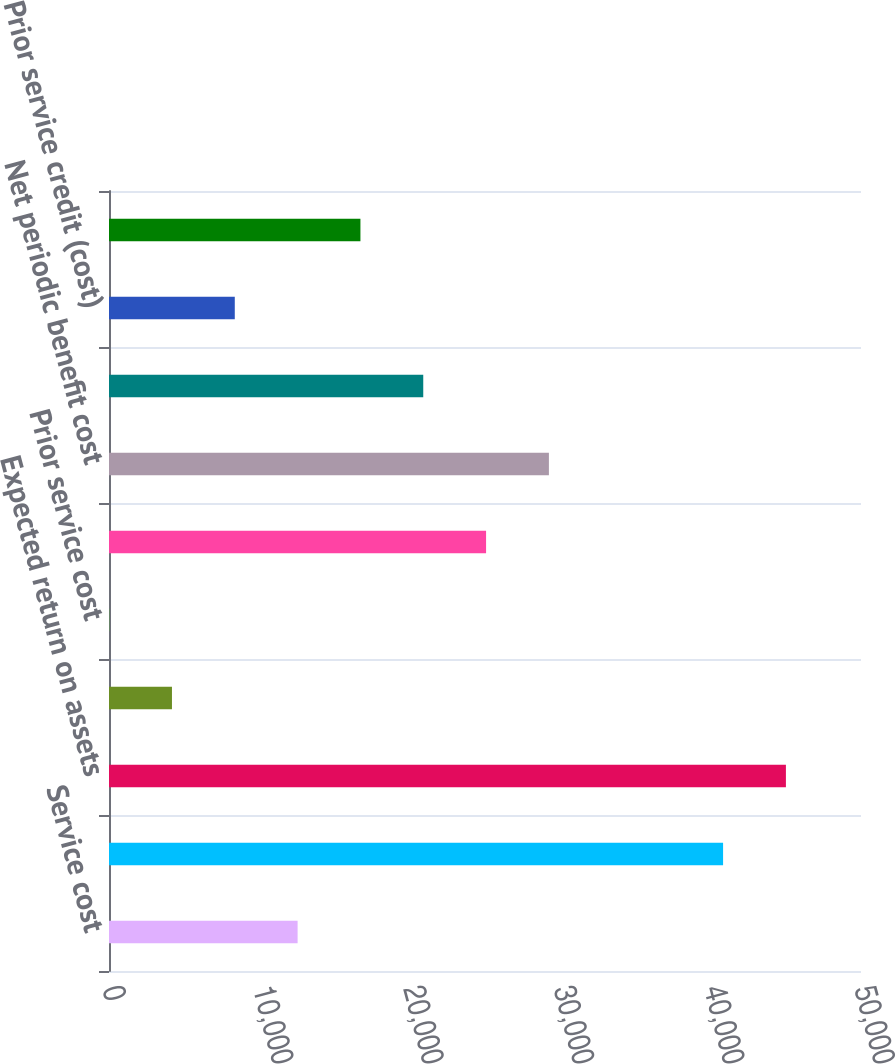<chart> <loc_0><loc_0><loc_500><loc_500><bar_chart><fcel>Service cost<fcel>Interest cost<fcel>Expected return on assets<fcel>Settlement cost<fcel>Prior service cost<fcel>Net actuarial loss<fcel>Net periodic benefit cost<fcel>Net loss<fcel>Prior service credit (cost)<fcel>Total loss recognized in other<nl><fcel>12540.3<fcel>40830<fcel>45007.1<fcel>4186.1<fcel>9<fcel>25071.6<fcel>29248.7<fcel>20894.5<fcel>8363.2<fcel>16717.4<nl></chart> 